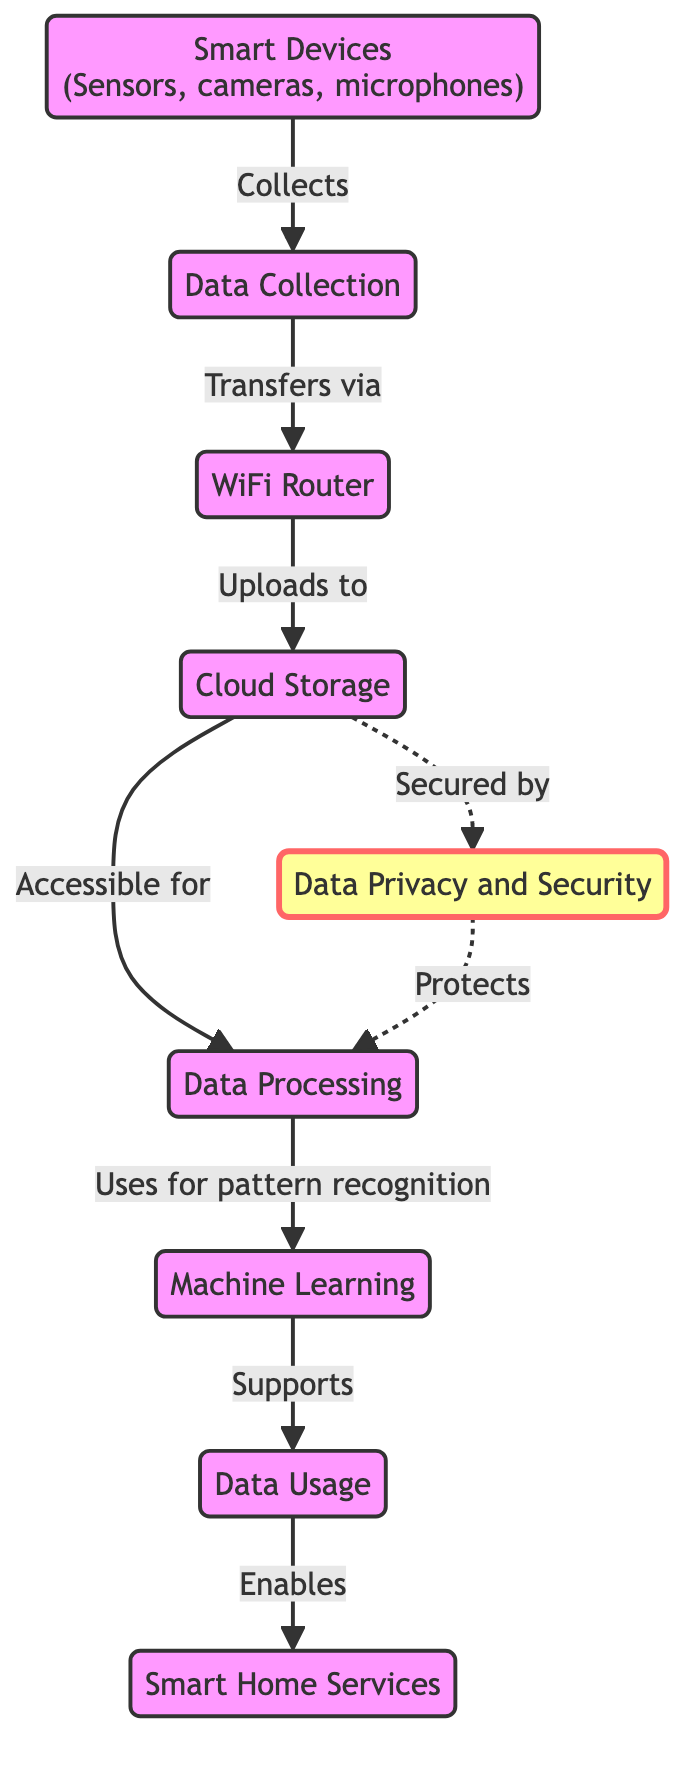What is the first node in the workflow? The first node is identified as "Smart Devices" which is connected to the data collection process, indicating where the workflow begins in the diagram.
Answer: Smart Devices How many nodes are in the diagram? By counting each unique element in the diagram, there are a total of eight nodes represented.
Answer: 8 What process follows data collection? Analyzing the flow direction in the diagram, the process that immediately comes after data collection is the WiFi router that transfers the data to the next step.
Answer: WiFi Router Which node is responsible for securing cloud storage? The diagram indicates that data privacy acts as a protective measure for cloud storage, highlighting its importance in maintaining security.
Answer: Data Privacy What does machine learning support in the workflow? By examining the connections, machine learning is shown to support data usage, demonstrating its role in enhancing service functionality within the smart home context.
Answer: Data Usage How is data collection achieved according to the diagram? The diagram states that data is collected by smart devices, which clearly outlines their function in gathering data within the smart home ecosystem.
Answer: By Smart Devices What are the services enabled by data usage? Looking at the direction of flow, it is evident that smart home services are enabled through the data usage process, highlighting its end goal in the workflow.
Answer: Smart Home Services How does data privacy relate to data processing? Data privacy is depicted to protect data processing in the diagram, indicating that privacy measures also safeguard the integrity of the processing activities.
Answer: Protects What is the primary function of cloud storage in the workflow? Based on the connections in the diagram, the primary function of cloud storage is to provide accessibility for data processing, allowing for data analysis and interpretation.
Answer: Accessible for Data Processing 